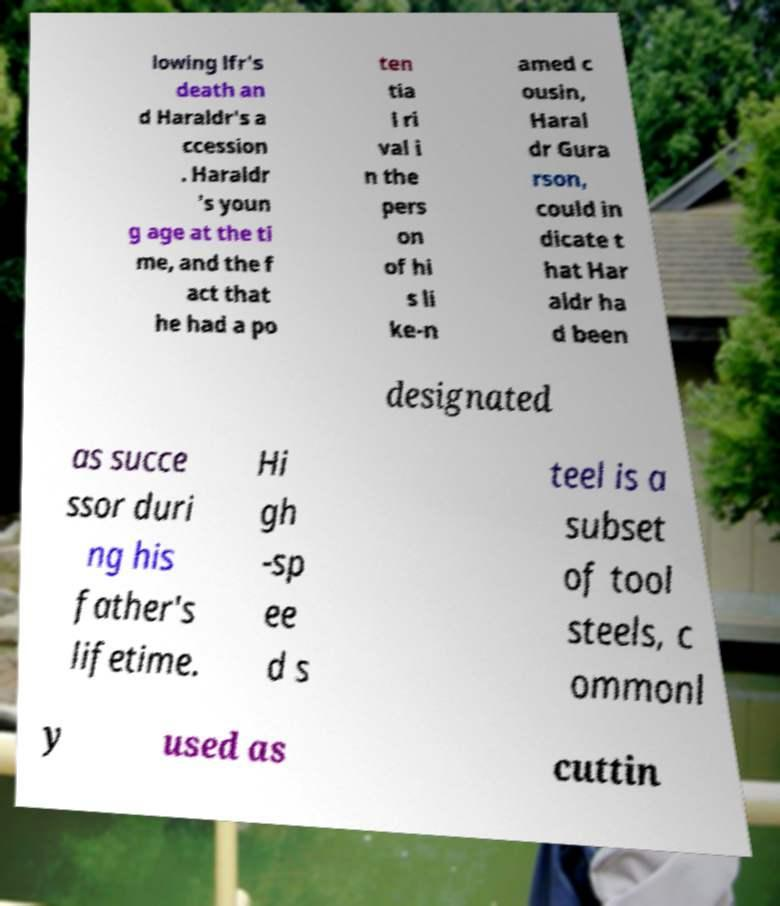What messages or text are displayed in this image? I need them in a readable, typed format. lowing lfr's death an d Haraldr's a ccession . Haraldr 's youn g age at the ti me, and the f act that he had a po ten tia l ri val i n the pers on of hi s li ke-n amed c ousin, Haral dr Gura rson, could in dicate t hat Har aldr ha d been designated as succe ssor duri ng his father's lifetime. Hi gh -sp ee d s teel is a subset of tool steels, c ommonl y used as cuttin 